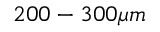<formula> <loc_0><loc_0><loc_500><loc_500>2 0 0 - 3 0 0 \mu m</formula> 